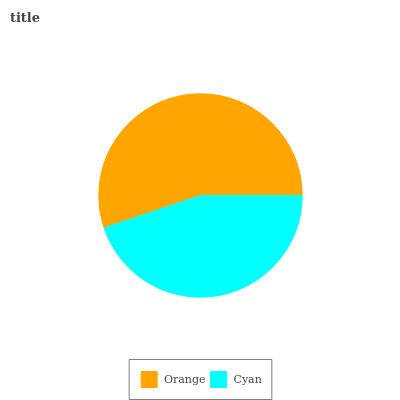Is Cyan the minimum?
Answer yes or no. Yes. Is Orange the maximum?
Answer yes or no. Yes. Is Cyan the maximum?
Answer yes or no. No. Is Orange greater than Cyan?
Answer yes or no. Yes. Is Cyan less than Orange?
Answer yes or no. Yes. Is Cyan greater than Orange?
Answer yes or no. No. Is Orange less than Cyan?
Answer yes or no. No. Is Orange the high median?
Answer yes or no. Yes. Is Cyan the low median?
Answer yes or no. Yes. Is Cyan the high median?
Answer yes or no. No. Is Orange the low median?
Answer yes or no. No. 